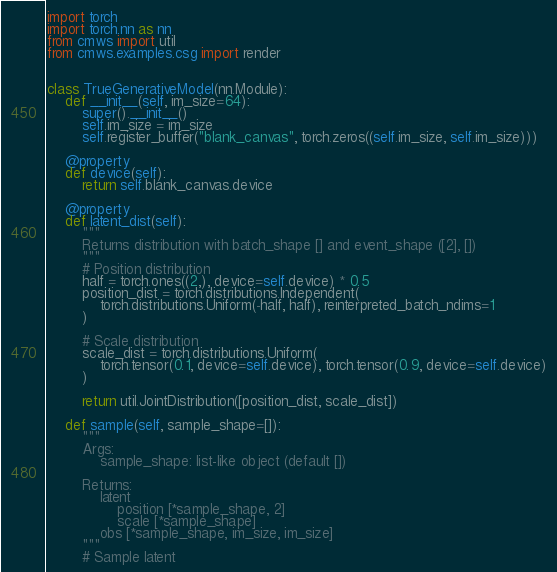<code> <loc_0><loc_0><loc_500><loc_500><_Python_>import torch
import torch.nn as nn
from cmws import util
from cmws.examples.csg import render


class TrueGenerativeModel(nn.Module):
    def __init__(self, im_size=64):
        super().__init__()
        self.im_size = im_size
        self.register_buffer("blank_canvas", torch.zeros((self.im_size, self.im_size)))

    @property
    def device(self):
        return self.blank_canvas.device

    @property
    def latent_dist(self):
        """
        Returns distribution with batch_shape [] and event_shape ([2], [])
        """
        # Position distribution
        half = torch.ones((2,), device=self.device) * 0.5
        position_dist = torch.distributions.Independent(
            torch.distributions.Uniform(-half, half), reinterpreted_batch_ndims=1
        )

        # Scale distribution
        scale_dist = torch.distributions.Uniform(
            torch.tensor(0.1, device=self.device), torch.tensor(0.9, device=self.device)
        )

        return util.JointDistribution([position_dist, scale_dist])

    def sample(self, sample_shape=[]):
        """
        Args:
            sample_shape: list-like object (default [])

        Returns:
            latent
                position [*sample_shape, 2]
                scale [*sample_shape]
            obs [*sample_shape, im_size, im_size]
        """
        # Sample latent</code> 